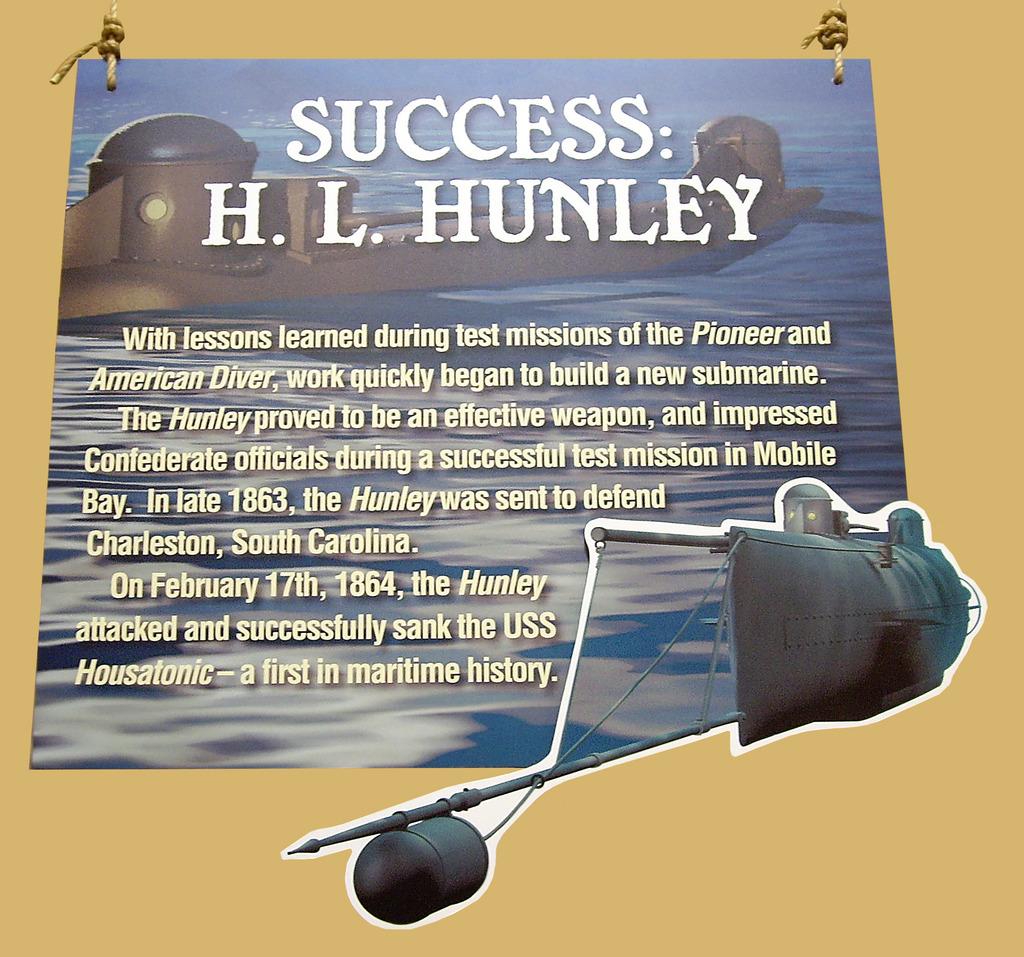When was the hunley attacked?
Make the answer very short. February 17 1864. Who wrote this?
Your answer should be very brief. H.l. hunley. 